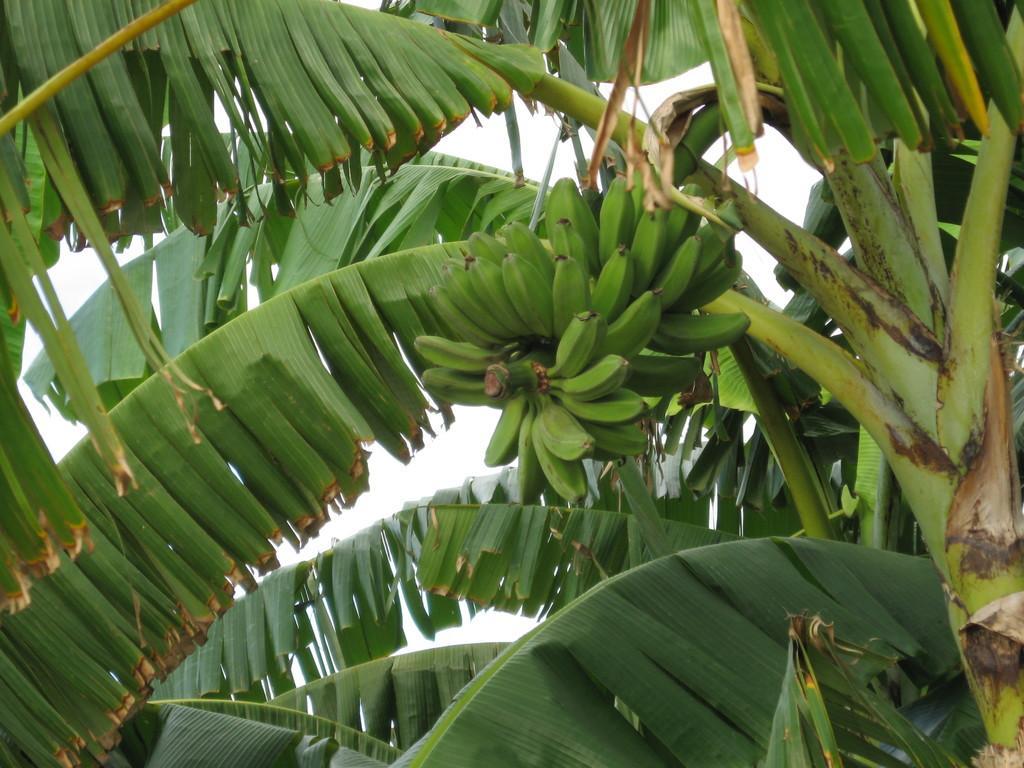In one or two sentences, can you explain what this image depicts? In this picture we can see bananas, branches and leaves. In the background of the image we can see the sky. 